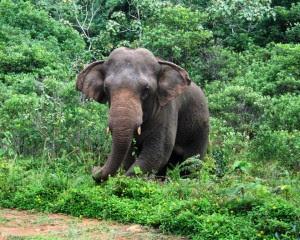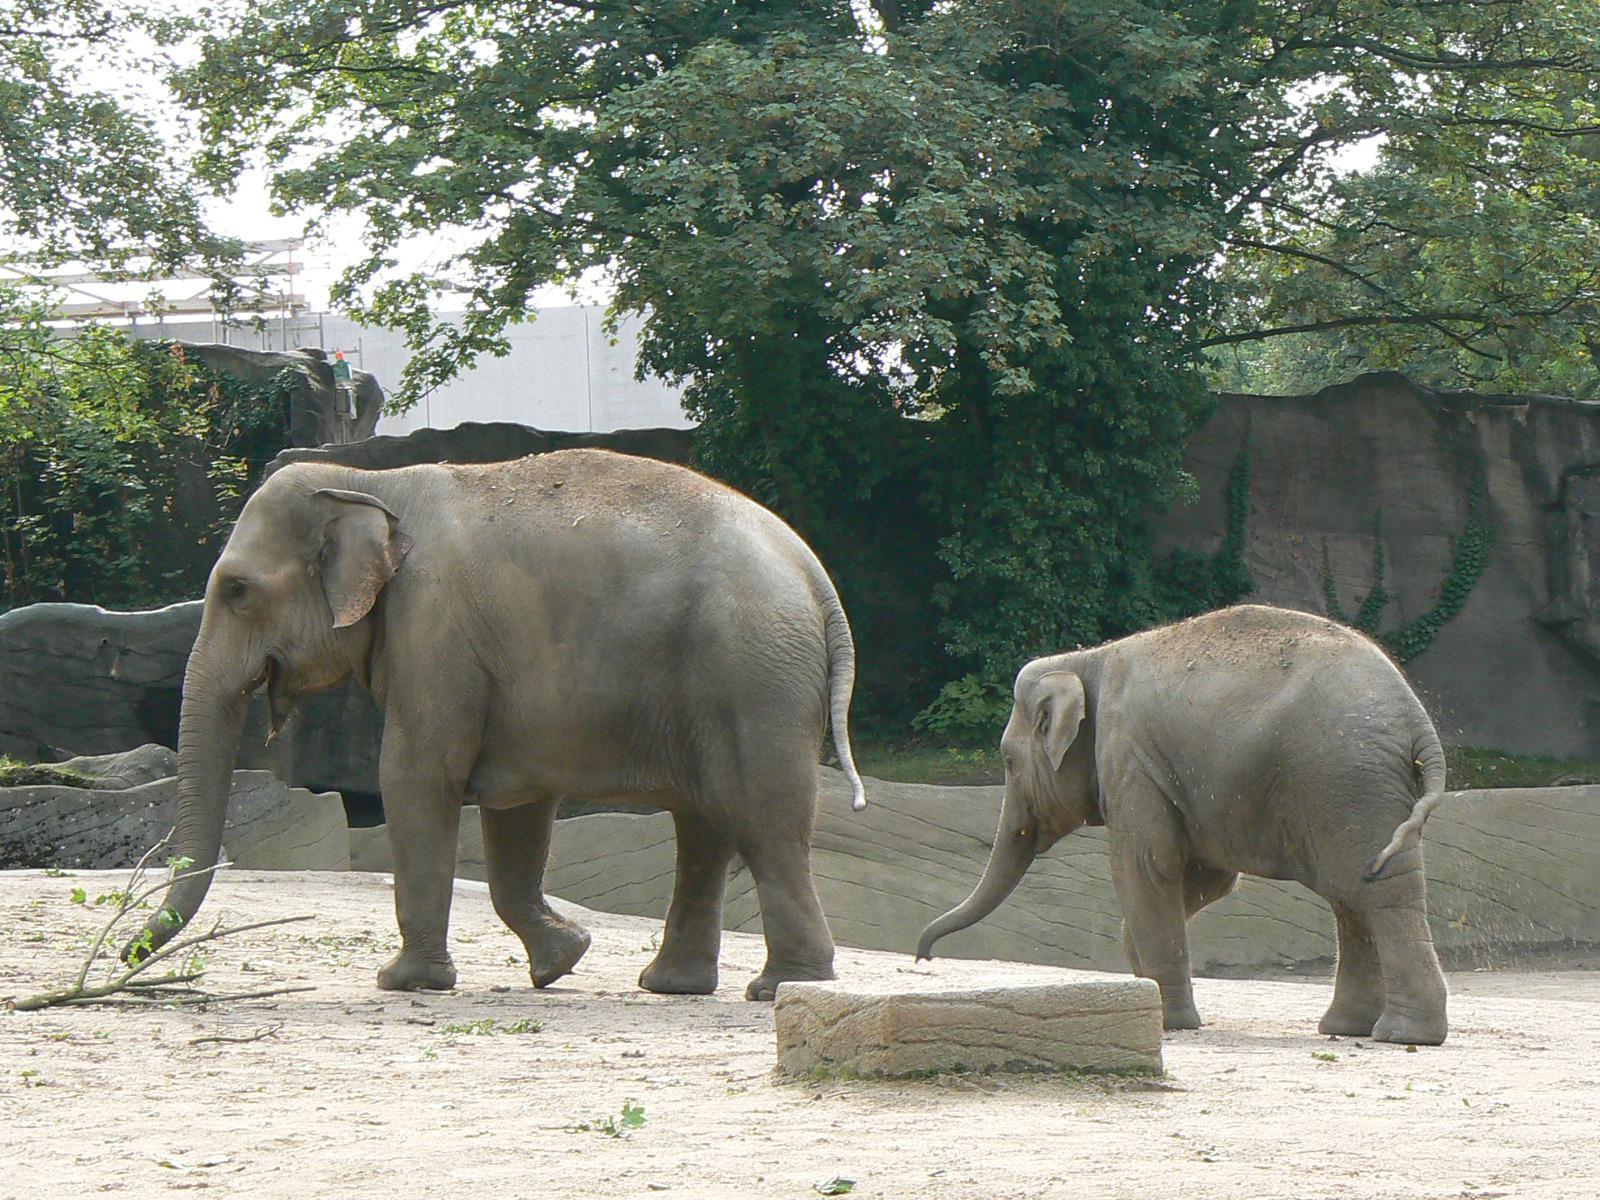The first image is the image on the left, the second image is the image on the right. For the images displayed, is the sentence "There is exactly two elephants in the right image." factually correct? Answer yes or no. Yes. The first image is the image on the left, the second image is the image on the right. Assess this claim about the two images: "The left image shows one lone adult elephant, while the right image shows one adult elephant with one younger elephant beside it". Correct or not? Answer yes or no. Yes. 